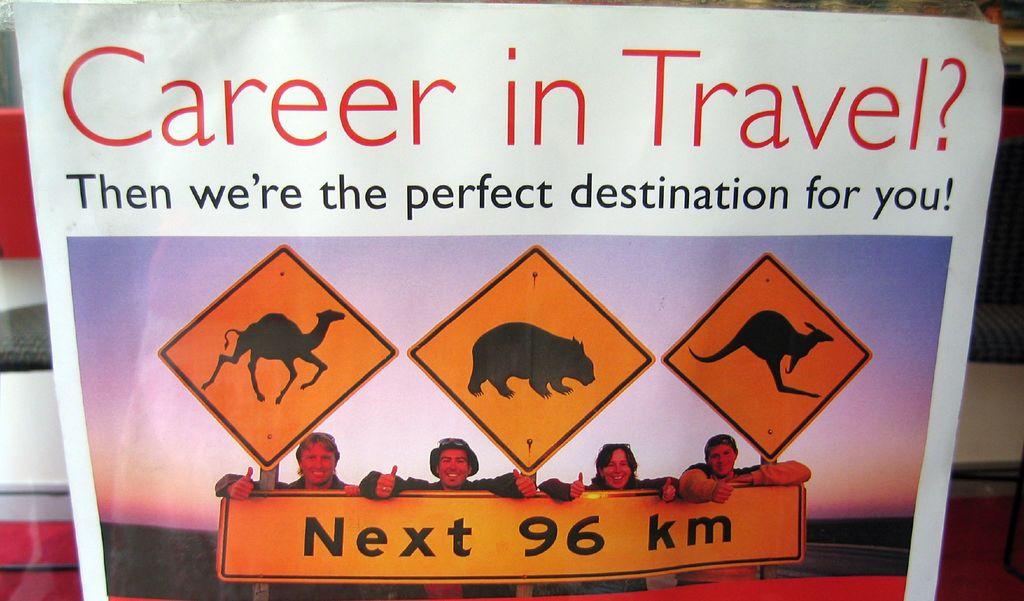What type of career is this advertising?
Your response must be concise. Travel. Next how many km?
Your response must be concise. 96. 